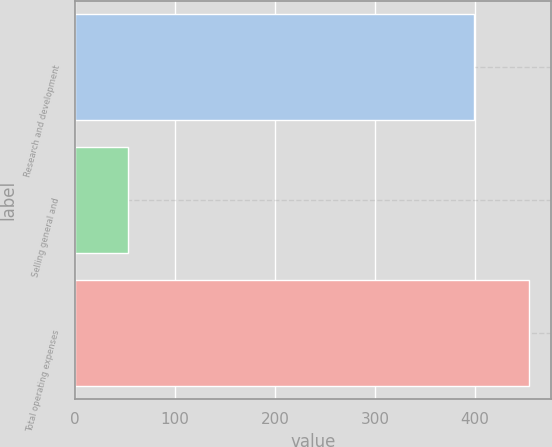Convert chart to OTSL. <chart><loc_0><loc_0><loc_500><loc_500><bar_chart><fcel>Research and development<fcel>Selling general and<fcel>Total operating expenses<nl><fcel>398.8<fcel>52.9<fcel>453.4<nl></chart> 